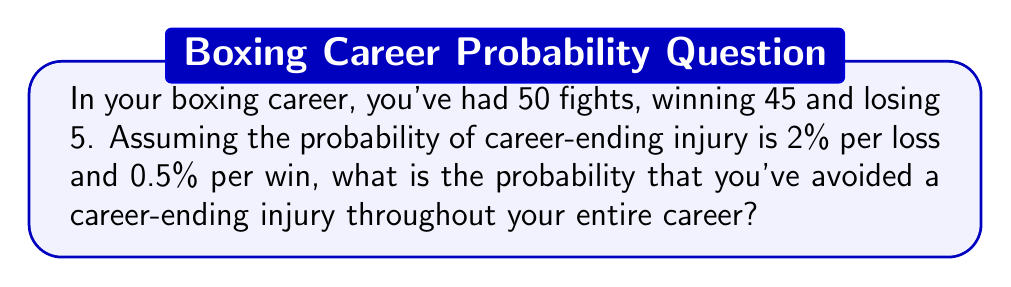What is the answer to this math problem? Let's approach this step-by-step:

1) First, we need to calculate the probability of avoiding a career-ending injury in each type of fight:

   For a win: $P(\text{no injury | win}) = 1 - 0.005 = 0.995$
   For a loss: $P(\text{no injury | loss}) = 1 - 0.02 = 0.98$

2) Now, we need to consider all fights. The probability of avoiding injury in all fights is the product of avoiding injury in each individual fight:

   $P(\text{no injury in career}) = P(\text{no injury in wins})^{45} \times P(\text{no injury in losses})^5$

3) Substituting the values:

   $P(\text{no injury in career}) = (0.995)^{45} \times (0.98)^5$

4) Let's calculate this step-by-step:

   $(0.995)^{45} \approx 0.7984$
   $(0.98)^5 \approx 0.9039$

5) Multiplying these together:

   $0.7984 \times 0.9039 \approx 0.7217$

6) Converting to a percentage:

   $0.7217 \times 100\% \approx 72.17\%$

Thus, the probability of avoiding a career-ending injury throughout your entire career is approximately 72.17%.
Answer: 72.17% 